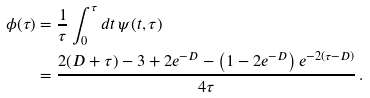Convert formula to latex. <formula><loc_0><loc_0><loc_500><loc_500>\phi ( \tau ) & = \frac { 1 } { \tau } \int _ { 0 } ^ { \tau } d t \, \psi ( t , \tau ) \\ & = \frac { 2 ( D + \tau ) - 3 + 2 e ^ { - D } - \left ( 1 - 2 e ^ { - D } \right ) e ^ { - 2 ( \tau - D ) } } { 4 \tau } \, .</formula> 